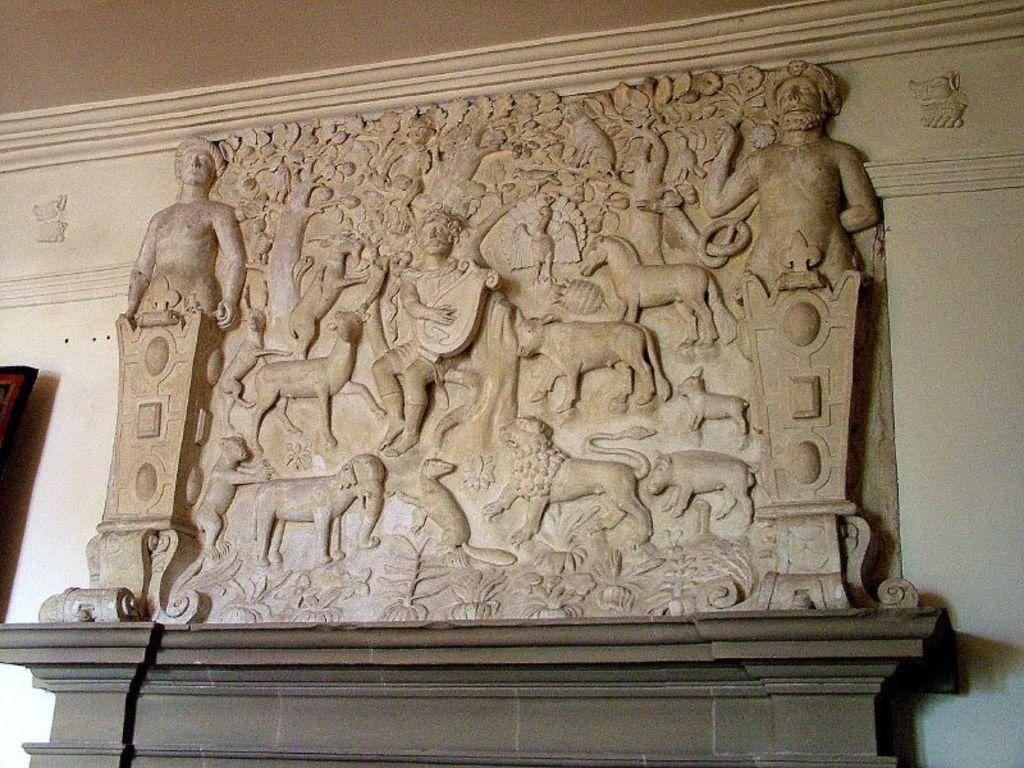What type of artwork is featured in the image? There is a relief art or stone carving in the image. What is the background of the artwork? There is a white wall behind the relief art or stone carving. Are there any other objects or features on the wall? Yes, a photo frame is placed on the white wall. What part of the room can be seen at the top of the image? The roof of the room is visible at the top of the image. Can you tell me how many needles are used to create the relief art in the image? There is no mention of needles being used to create the relief art in the image. The relief art or stone carving is likely created using other tools and techniques. 